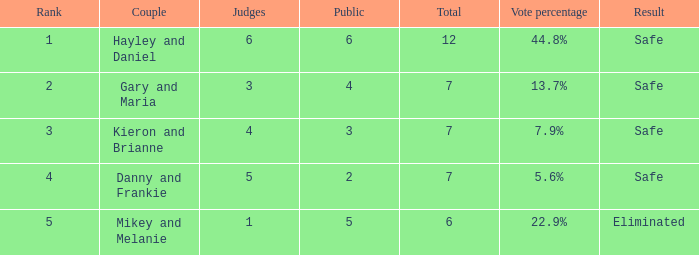How many people were there when the vote percentage stood at 22.9%? 1.0. 